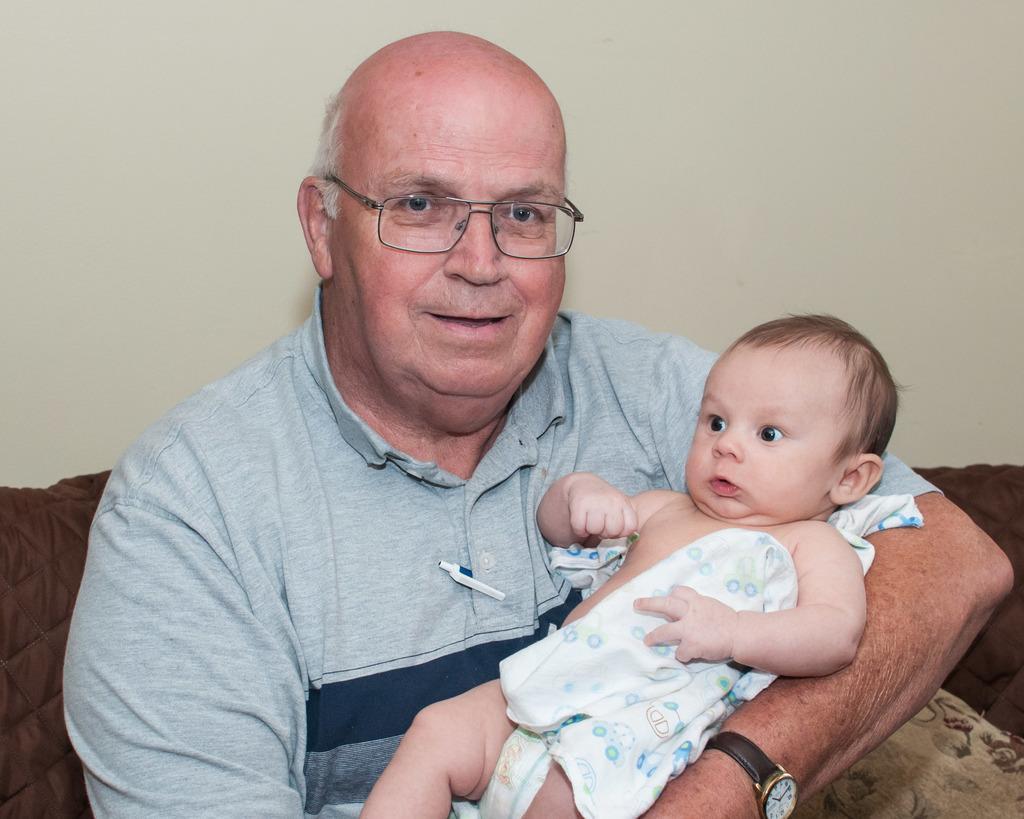Could you give a brief overview of what you see in this image? In the center of the image there is a old person holding a baby. In the background of the image there is a wall. 